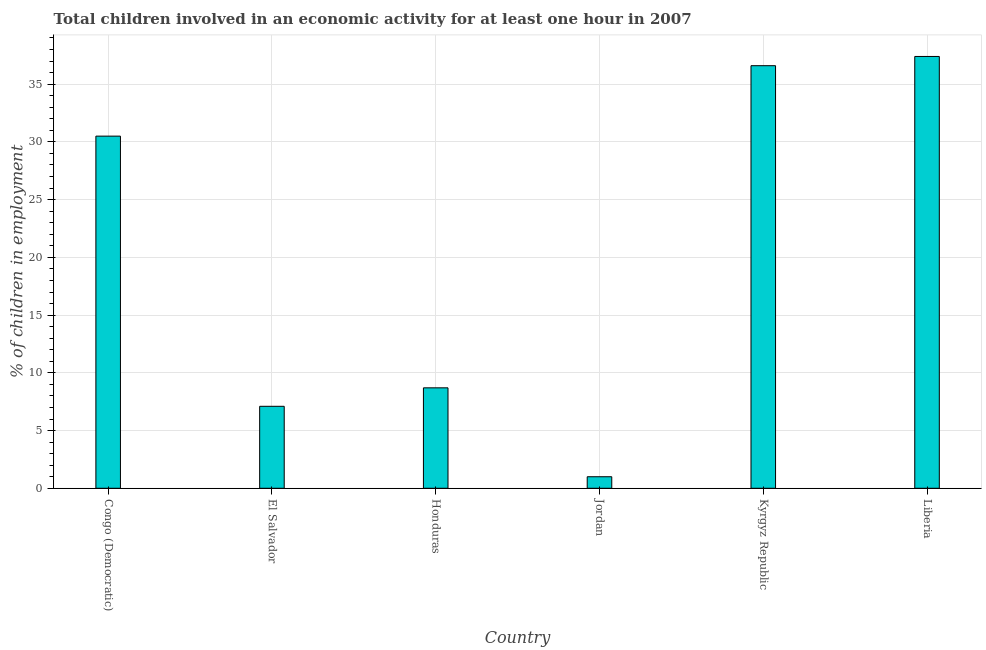Does the graph contain any zero values?
Provide a short and direct response. No. Does the graph contain grids?
Ensure brevity in your answer.  Yes. What is the title of the graph?
Offer a terse response. Total children involved in an economic activity for at least one hour in 2007. What is the label or title of the X-axis?
Your response must be concise. Country. What is the label or title of the Y-axis?
Your answer should be compact. % of children in employment. What is the percentage of children in employment in El Salvador?
Ensure brevity in your answer.  7.1. Across all countries, what is the maximum percentage of children in employment?
Offer a terse response. 37.4. In which country was the percentage of children in employment maximum?
Give a very brief answer. Liberia. In which country was the percentage of children in employment minimum?
Your response must be concise. Jordan. What is the sum of the percentage of children in employment?
Your answer should be very brief. 121.3. What is the average percentage of children in employment per country?
Offer a terse response. 20.22. What is the median percentage of children in employment?
Provide a succinct answer. 19.6. What is the ratio of the percentage of children in employment in El Salvador to that in Kyrgyz Republic?
Ensure brevity in your answer.  0.19. Is the percentage of children in employment in El Salvador less than that in Jordan?
Provide a short and direct response. No. Is the difference between the percentage of children in employment in Congo (Democratic) and Liberia greater than the difference between any two countries?
Your response must be concise. No. What is the difference between the highest and the lowest percentage of children in employment?
Your response must be concise. 36.4. How many countries are there in the graph?
Offer a very short reply. 6. What is the difference between two consecutive major ticks on the Y-axis?
Offer a very short reply. 5. What is the % of children in employment of Congo (Democratic)?
Offer a terse response. 30.5. What is the % of children in employment in Honduras?
Your response must be concise. 8.7. What is the % of children in employment of Kyrgyz Republic?
Keep it short and to the point. 36.6. What is the % of children in employment of Liberia?
Provide a succinct answer. 37.4. What is the difference between the % of children in employment in Congo (Democratic) and El Salvador?
Offer a very short reply. 23.4. What is the difference between the % of children in employment in Congo (Democratic) and Honduras?
Offer a very short reply. 21.8. What is the difference between the % of children in employment in Congo (Democratic) and Jordan?
Make the answer very short. 29.5. What is the difference between the % of children in employment in Congo (Democratic) and Kyrgyz Republic?
Offer a very short reply. -6.1. What is the difference between the % of children in employment in Congo (Democratic) and Liberia?
Provide a succinct answer. -6.9. What is the difference between the % of children in employment in El Salvador and Honduras?
Ensure brevity in your answer.  -1.6. What is the difference between the % of children in employment in El Salvador and Kyrgyz Republic?
Give a very brief answer. -29.5. What is the difference between the % of children in employment in El Salvador and Liberia?
Ensure brevity in your answer.  -30.3. What is the difference between the % of children in employment in Honduras and Jordan?
Your answer should be compact. 7.7. What is the difference between the % of children in employment in Honduras and Kyrgyz Republic?
Give a very brief answer. -27.9. What is the difference between the % of children in employment in Honduras and Liberia?
Provide a succinct answer. -28.7. What is the difference between the % of children in employment in Jordan and Kyrgyz Republic?
Give a very brief answer. -35.6. What is the difference between the % of children in employment in Jordan and Liberia?
Offer a very short reply. -36.4. What is the difference between the % of children in employment in Kyrgyz Republic and Liberia?
Keep it short and to the point. -0.8. What is the ratio of the % of children in employment in Congo (Democratic) to that in El Salvador?
Offer a terse response. 4.3. What is the ratio of the % of children in employment in Congo (Democratic) to that in Honduras?
Offer a very short reply. 3.51. What is the ratio of the % of children in employment in Congo (Democratic) to that in Jordan?
Provide a succinct answer. 30.5. What is the ratio of the % of children in employment in Congo (Democratic) to that in Kyrgyz Republic?
Offer a terse response. 0.83. What is the ratio of the % of children in employment in Congo (Democratic) to that in Liberia?
Your response must be concise. 0.82. What is the ratio of the % of children in employment in El Salvador to that in Honduras?
Offer a terse response. 0.82. What is the ratio of the % of children in employment in El Salvador to that in Kyrgyz Republic?
Your answer should be compact. 0.19. What is the ratio of the % of children in employment in El Salvador to that in Liberia?
Ensure brevity in your answer.  0.19. What is the ratio of the % of children in employment in Honduras to that in Jordan?
Your answer should be compact. 8.7. What is the ratio of the % of children in employment in Honduras to that in Kyrgyz Republic?
Provide a short and direct response. 0.24. What is the ratio of the % of children in employment in Honduras to that in Liberia?
Offer a terse response. 0.23. What is the ratio of the % of children in employment in Jordan to that in Kyrgyz Republic?
Your answer should be compact. 0.03. What is the ratio of the % of children in employment in Jordan to that in Liberia?
Provide a short and direct response. 0.03. What is the ratio of the % of children in employment in Kyrgyz Republic to that in Liberia?
Make the answer very short. 0.98. 